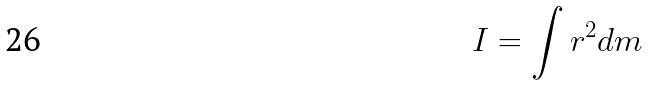<formula> <loc_0><loc_0><loc_500><loc_500>I = \int r ^ { 2 } d m</formula> 